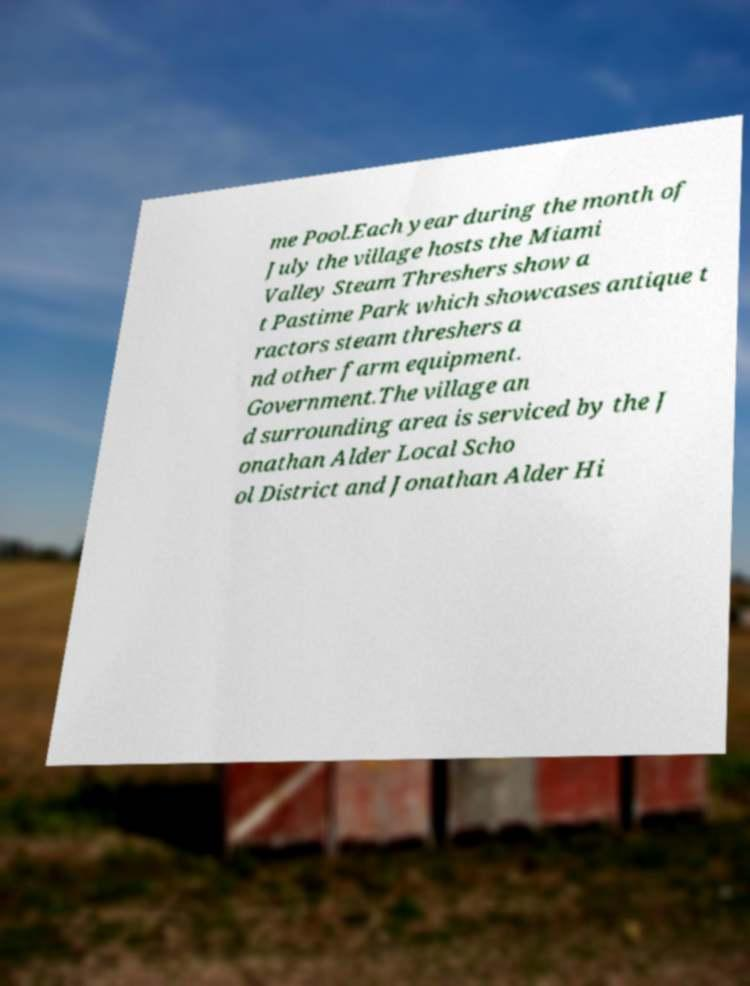Can you accurately transcribe the text from the provided image for me? me Pool.Each year during the month of July the village hosts the Miami Valley Steam Threshers show a t Pastime Park which showcases antique t ractors steam threshers a nd other farm equipment. Government.The village an d surrounding area is serviced by the J onathan Alder Local Scho ol District and Jonathan Alder Hi 